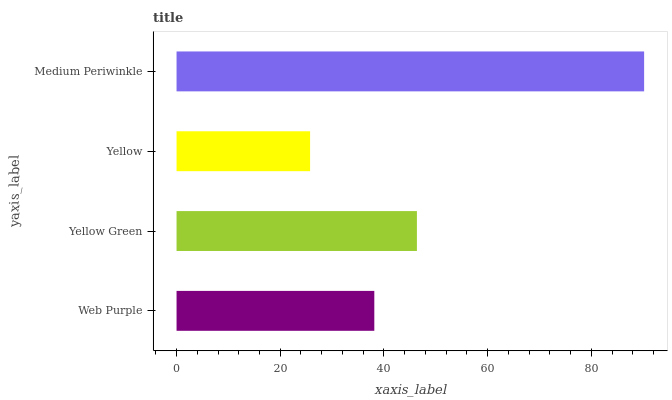Is Yellow the minimum?
Answer yes or no. Yes. Is Medium Periwinkle the maximum?
Answer yes or no. Yes. Is Yellow Green the minimum?
Answer yes or no. No. Is Yellow Green the maximum?
Answer yes or no. No. Is Yellow Green greater than Web Purple?
Answer yes or no. Yes. Is Web Purple less than Yellow Green?
Answer yes or no. Yes. Is Web Purple greater than Yellow Green?
Answer yes or no. No. Is Yellow Green less than Web Purple?
Answer yes or no. No. Is Yellow Green the high median?
Answer yes or no. Yes. Is Web Purple the low median?
Answer yes or no. Yes. Is Yellow the high median?
Answer yes or no. No. Is Medium Periwinkle the low median?
Answer yes or no. No. 